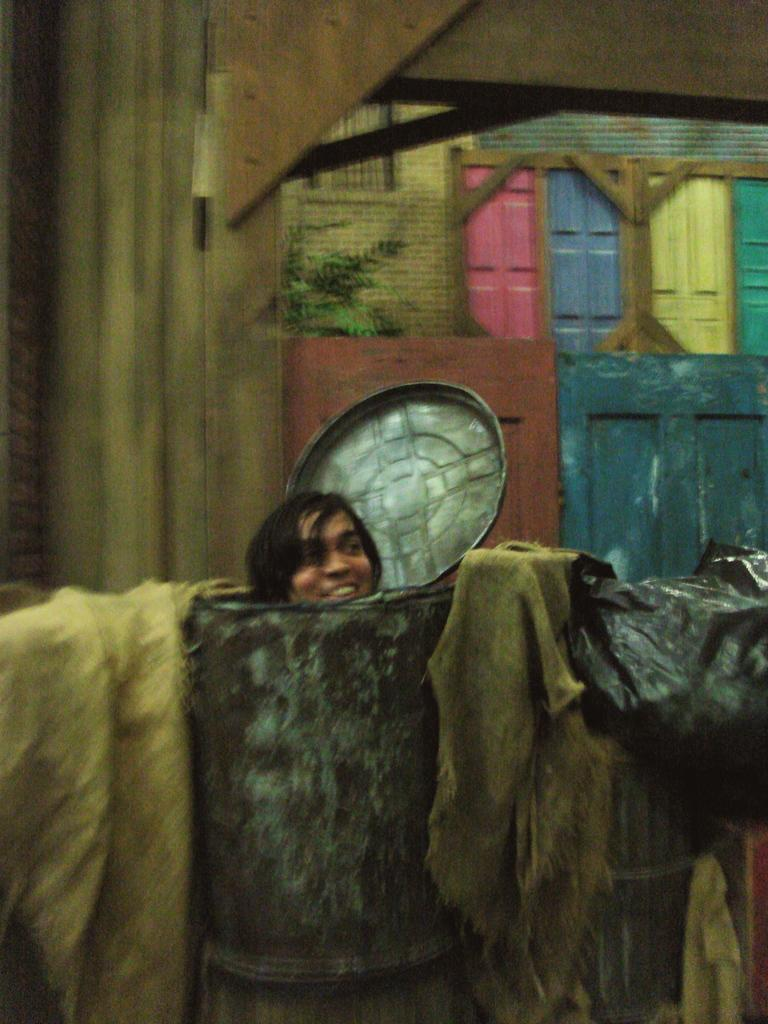What is the person in the foreground of the image doing? The person is standing in a barrel in the foreground of the image. What can be seen in the background of the image? There is a wall and windows in the background of the image. Where was the image taken? The image was taken in a room. What type of powder is being used by the maid in the image? There is no maid or powder present in the image. Is there a baseball game happening in the background of the image? There is no baseball game or any reference to sports in the image. 